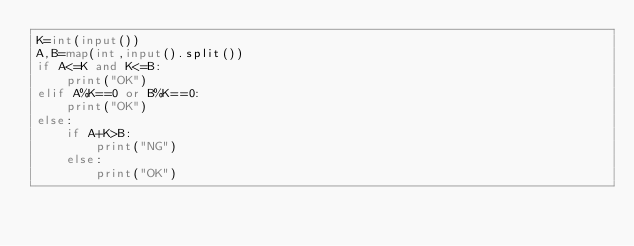Convert code to text. <code><loc_0><loc_0><loc_500><loc_500><_Python_>K=int(input())
A,B=map(int,input().split())
if A<=K and K<=B:
    print("OK")
elif A%K==0 or B%K==0:
    print("OK")
else:
    if A+K>B:
        print("NG")
    else:
        print("OK")
</code> 